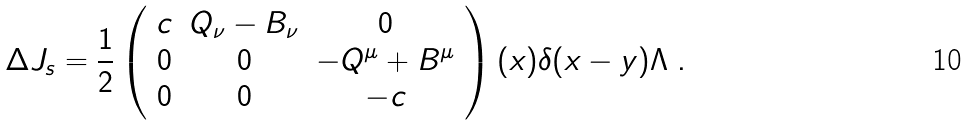<formula> <loc_0><loc_0><loc_500><loc_500>\Delta J _ { s } = \frac { 1 } { 2 } \left ( \begin{array} { c c c } c & Q _ { \nu } - B _ { \nu } & 0 \\ 0 & 0 & - Q ^ { \mu } + B ^ { \mu } \\ 0 & 0 & - c \end{array} \right ) ( x ) \delta ( x - y ) \Lambda \ .</formula> 